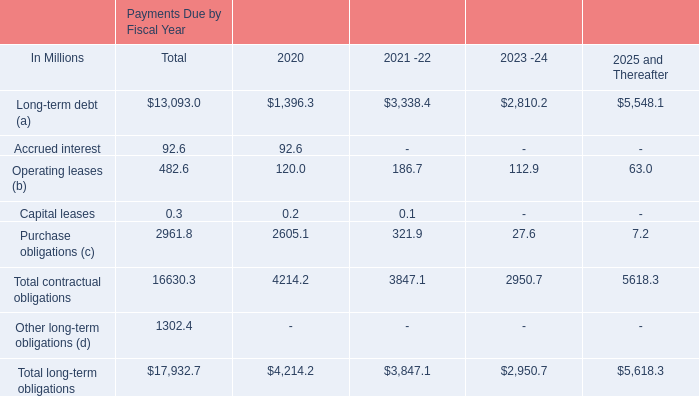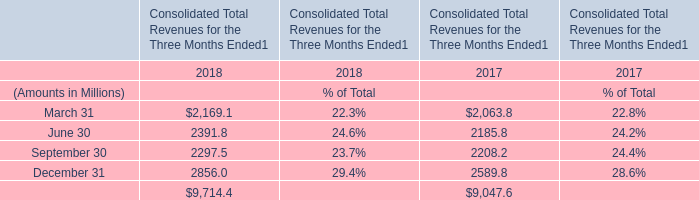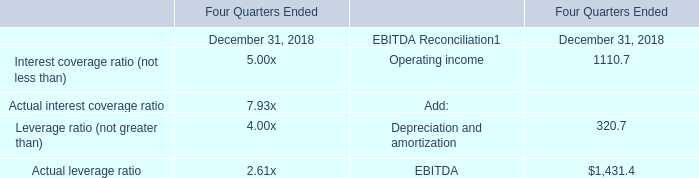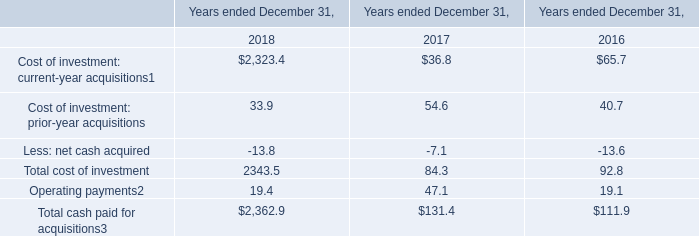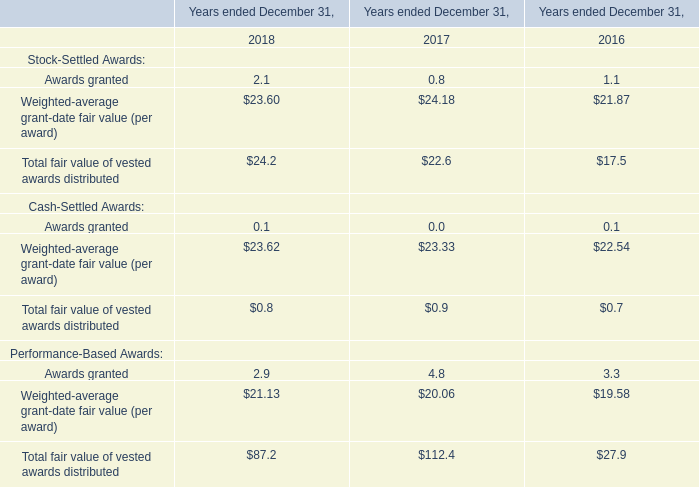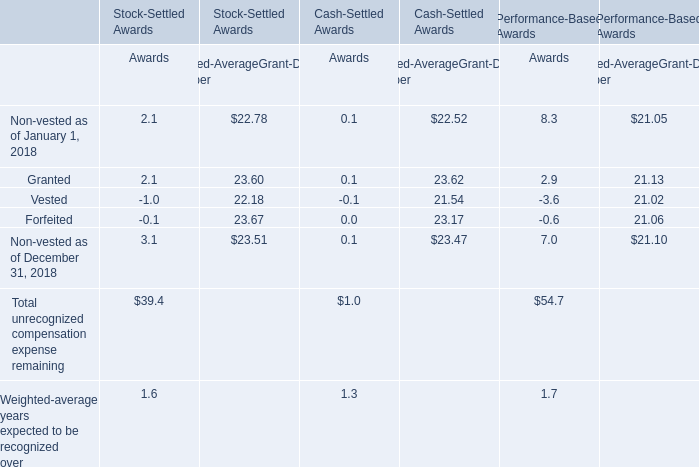Which section is Total unrecognized compensation expense remainingthe most? 
Answer: Performance-Based Awards. 